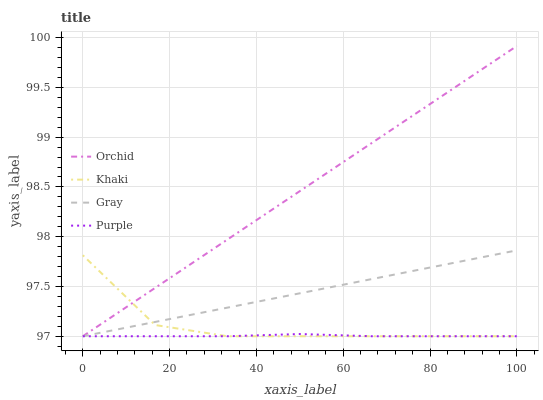Does Purple have the minimum area under the curve?
Answer yes or no. Yes. Does Orchid have the maximum area under the curve?
Answer yes or no. Yes. Does Gray have the minimum area under the curve?
Answer yes or no. No. Does Gray have the maximum area under the curve?
Answer yes or no. No. Is Gray the smoothest?
Answer yes or no. Yes. Is Khaki the roughest?
Answer yes or no. Yes. Is Khaki the smoothest?
Answer yes or no. No. Is Gray the roughest?
Answer yes or no. No. Does Purple have the lowest value?
Answer yes or no. Yes. Does Orchid have the highest value?
Answer yes or no. Yes. Does Gray have the highest value?
Answer yes or no. No. Does Gray intersect Purple?
Answer yes or no. Yes. Is Gray less than Purple?
Answer yes or no. No. Is Gray greater than Purple?
Answer yes or no. No. 